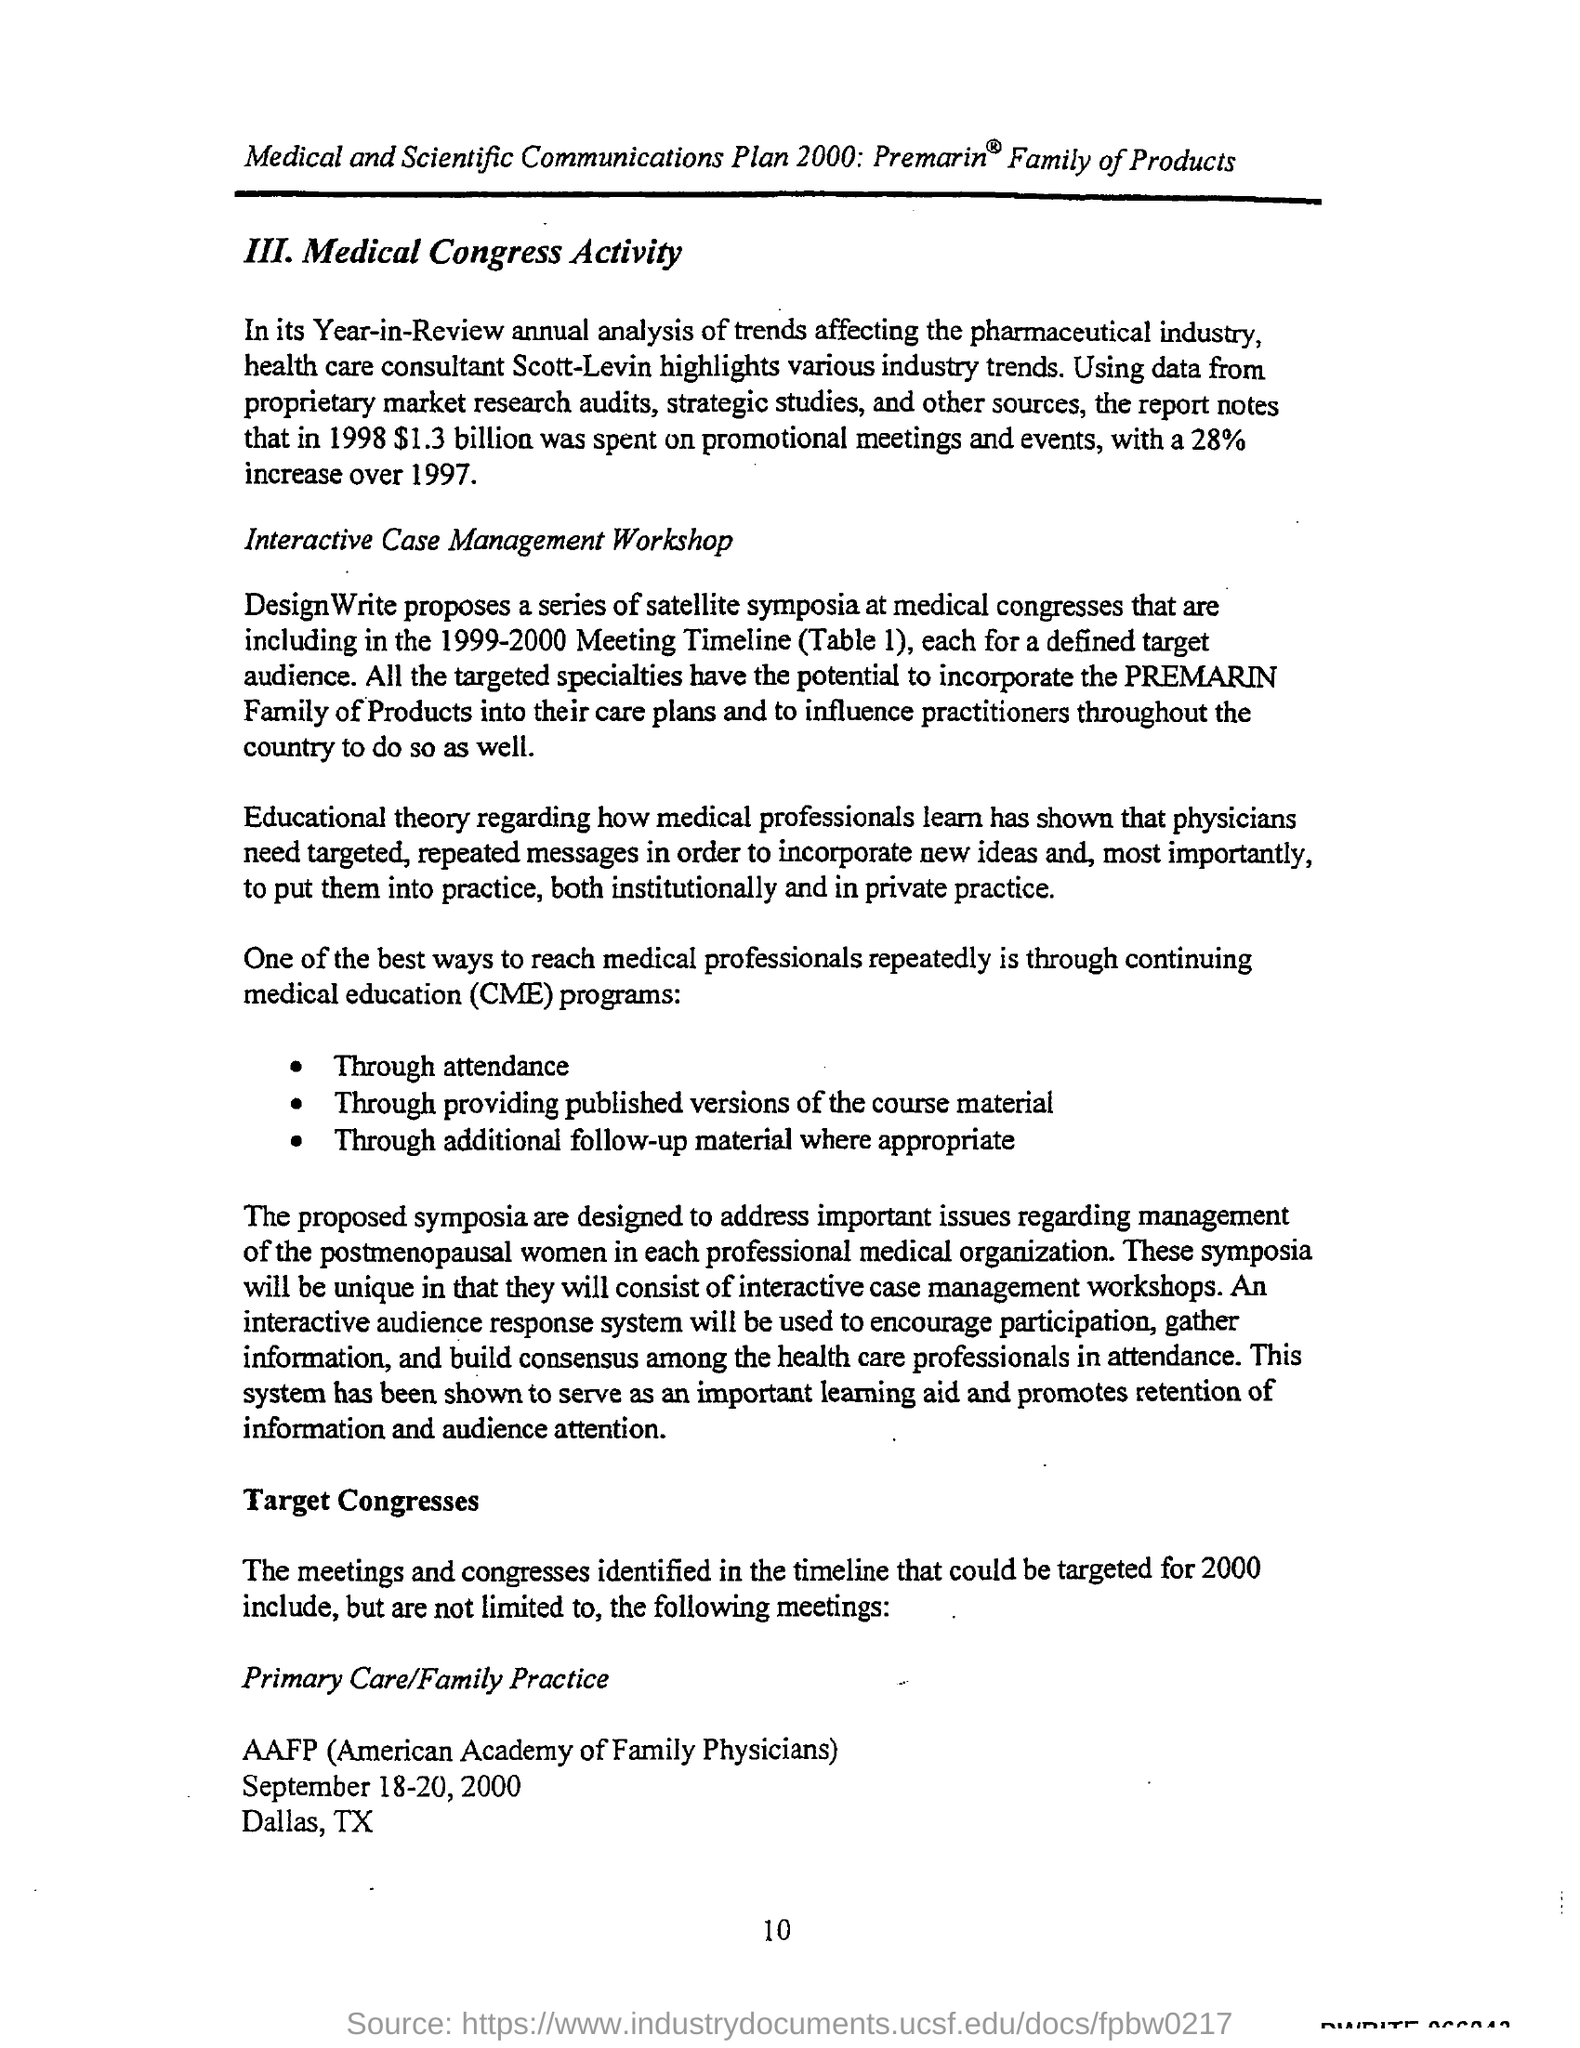Indicate a few pertinent items in this graphic. The page number is 10," the speaker declared. 